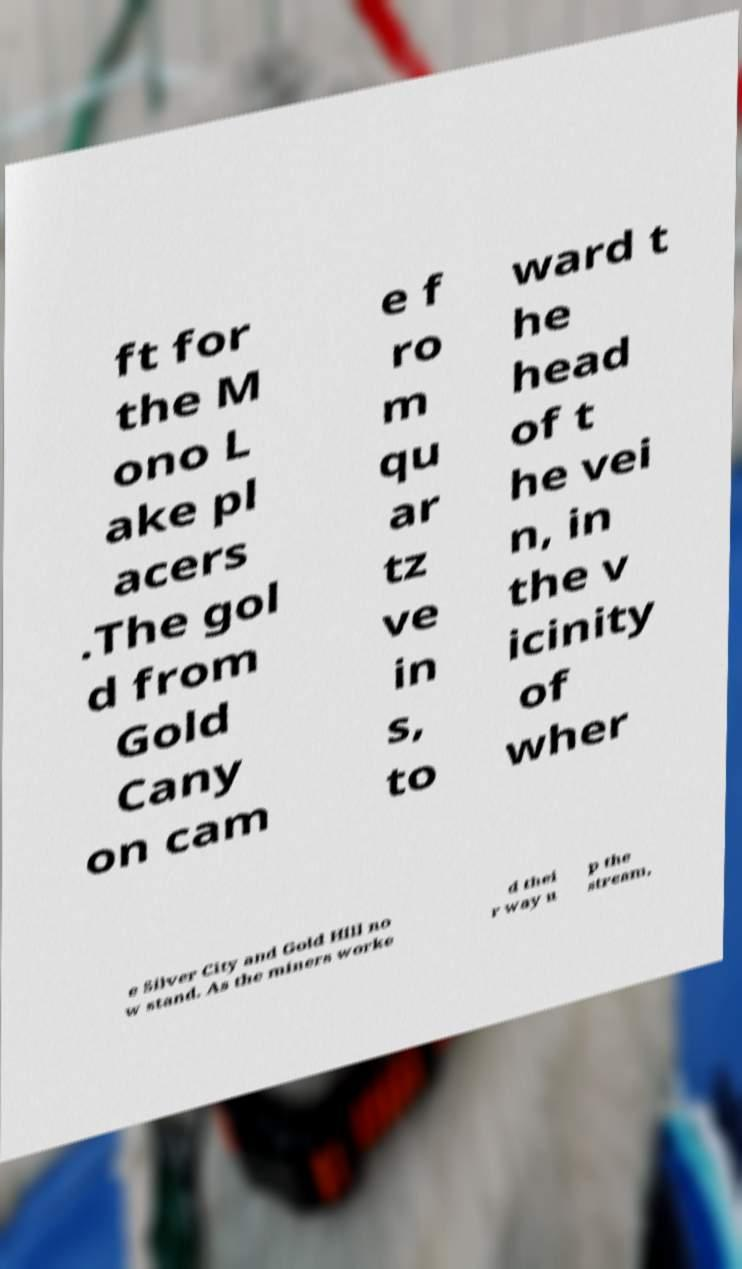Can you read and provide the text displayed in the image?This photo seems to have some interesting text. Can you extract and type it out for me? ft for the M ono L ake pl acers .The gol d from Gold Cany on cam e f ro m qu ar tz ve in s, to ward t he head of t he vei n, in the v icinity of wher e Silver City and Gold Hill no w stand. As the miners worke d thei r way u p the stream, 